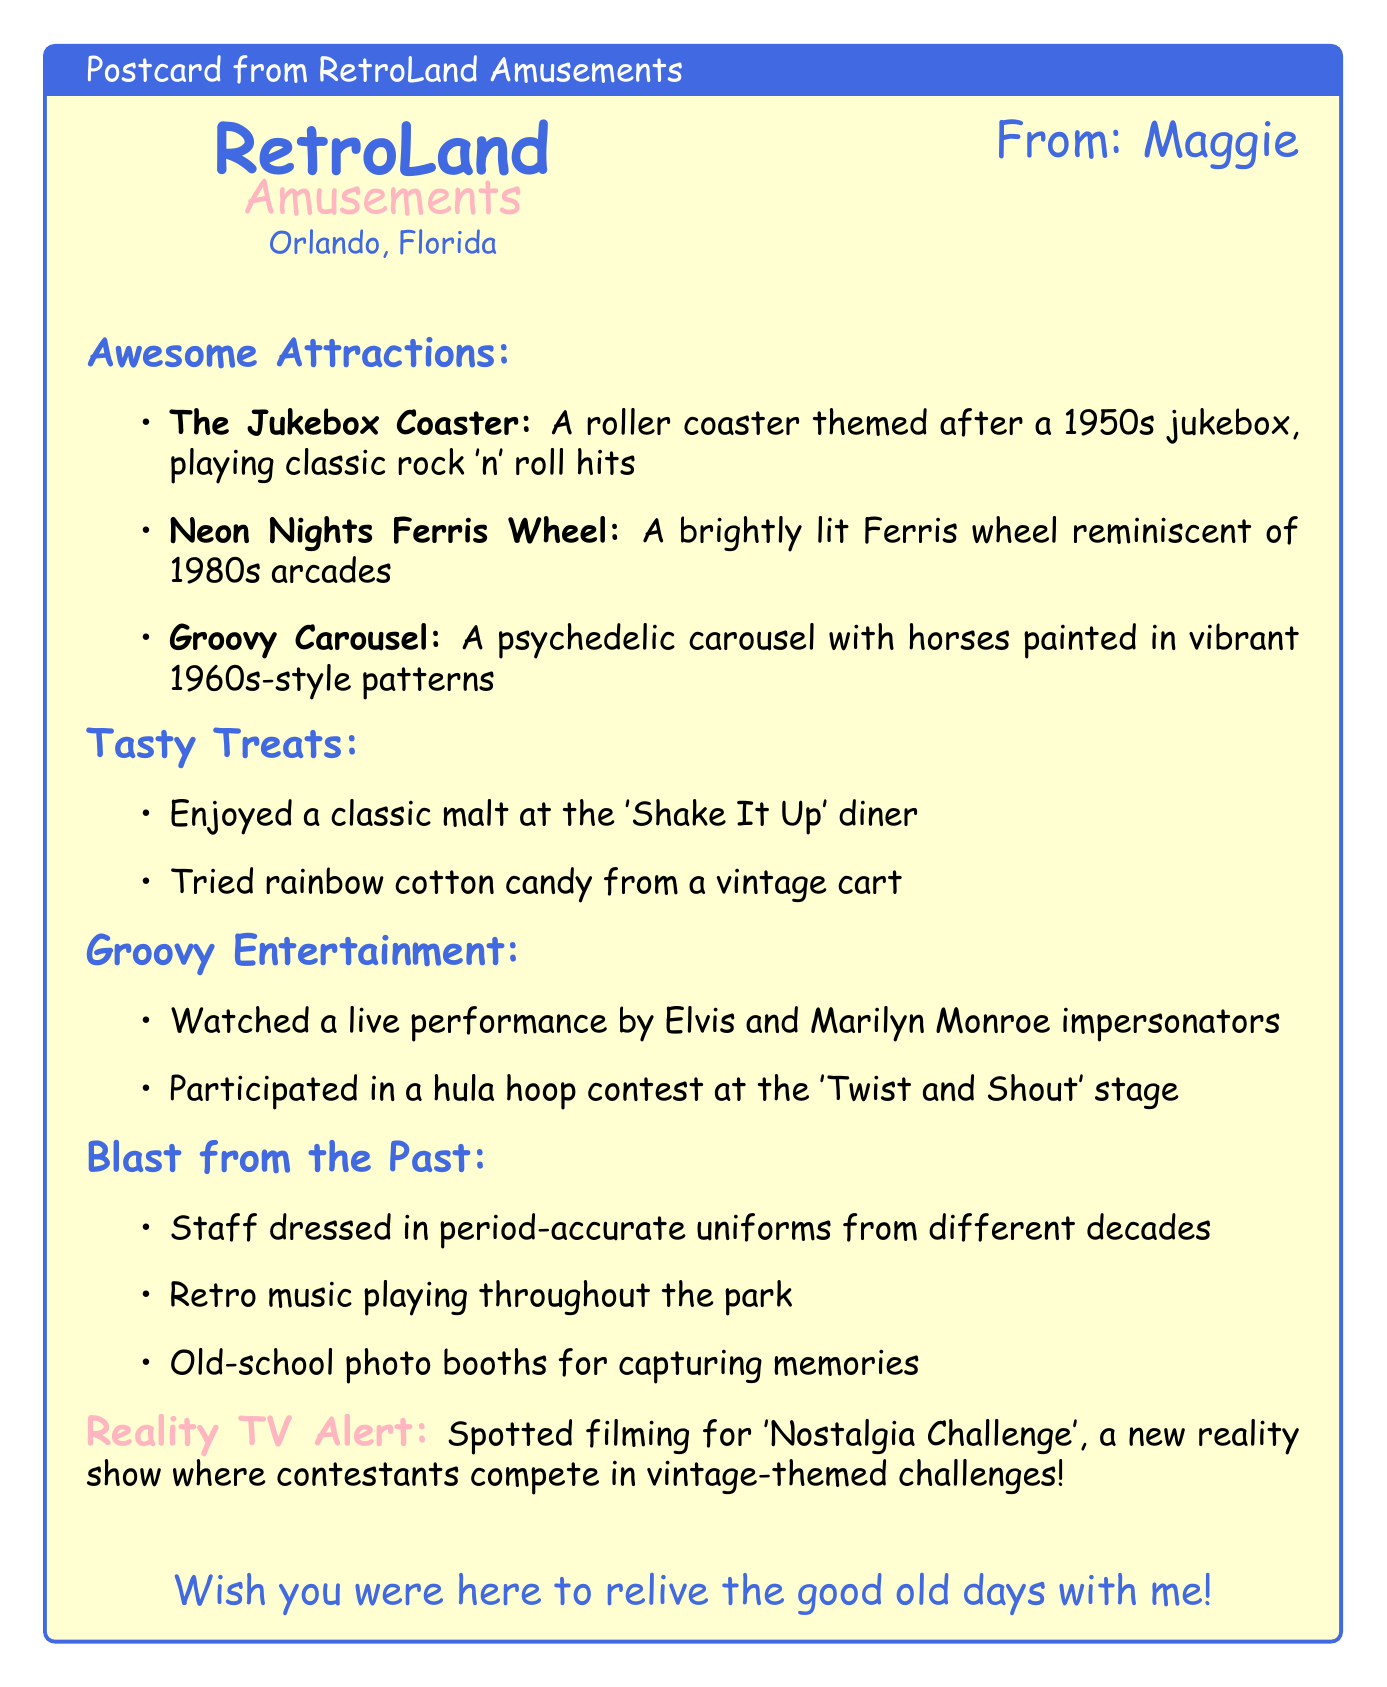What is the name of the amusement park? The name of the amusement park mentioned in the document is RetroLand Amusements.
Answer: RetroLand Amusements Where is RetroLand Amusements located? The document states that RetroLand Amusements is located in Orlando, Florida.
Answer: Orlando, Florida What is one of the attractions at the park? One of the attractions listed in the document is The Jukebox Coaster.
Answer: The Jukebox Coaster What unique food experience did Maggie have? Maggie enjoyed a classic malt at the 'Shake It Up' diner as mentioned in the document.
Answer: classic malt Which reality show was spotted filming at the park? The document indicates that filming for 'Nostalgia Challenge' was taking place at the park.
Answer: Nostalgia Challenge What decade is the Ferris wheel reminiscent of? The Ferris wheel is described as reminiscent of 1980s arcades in the document.
Answer: 1980s Name one nostalgic element found at the park. One nostalgic element mentioned is retro music playing throughout the park.
Answer: retro music Who performed live at the park? The document mentions a live performance by Elvis and Marilyn Monroe impersonators.
Answer: Elvis and Marilyn Monroe What did Maggie wish for at the end of the postcard? Maggie expressed a sentiment of wishing someone could relive the good old days with her.
Answer: relive the good old days 